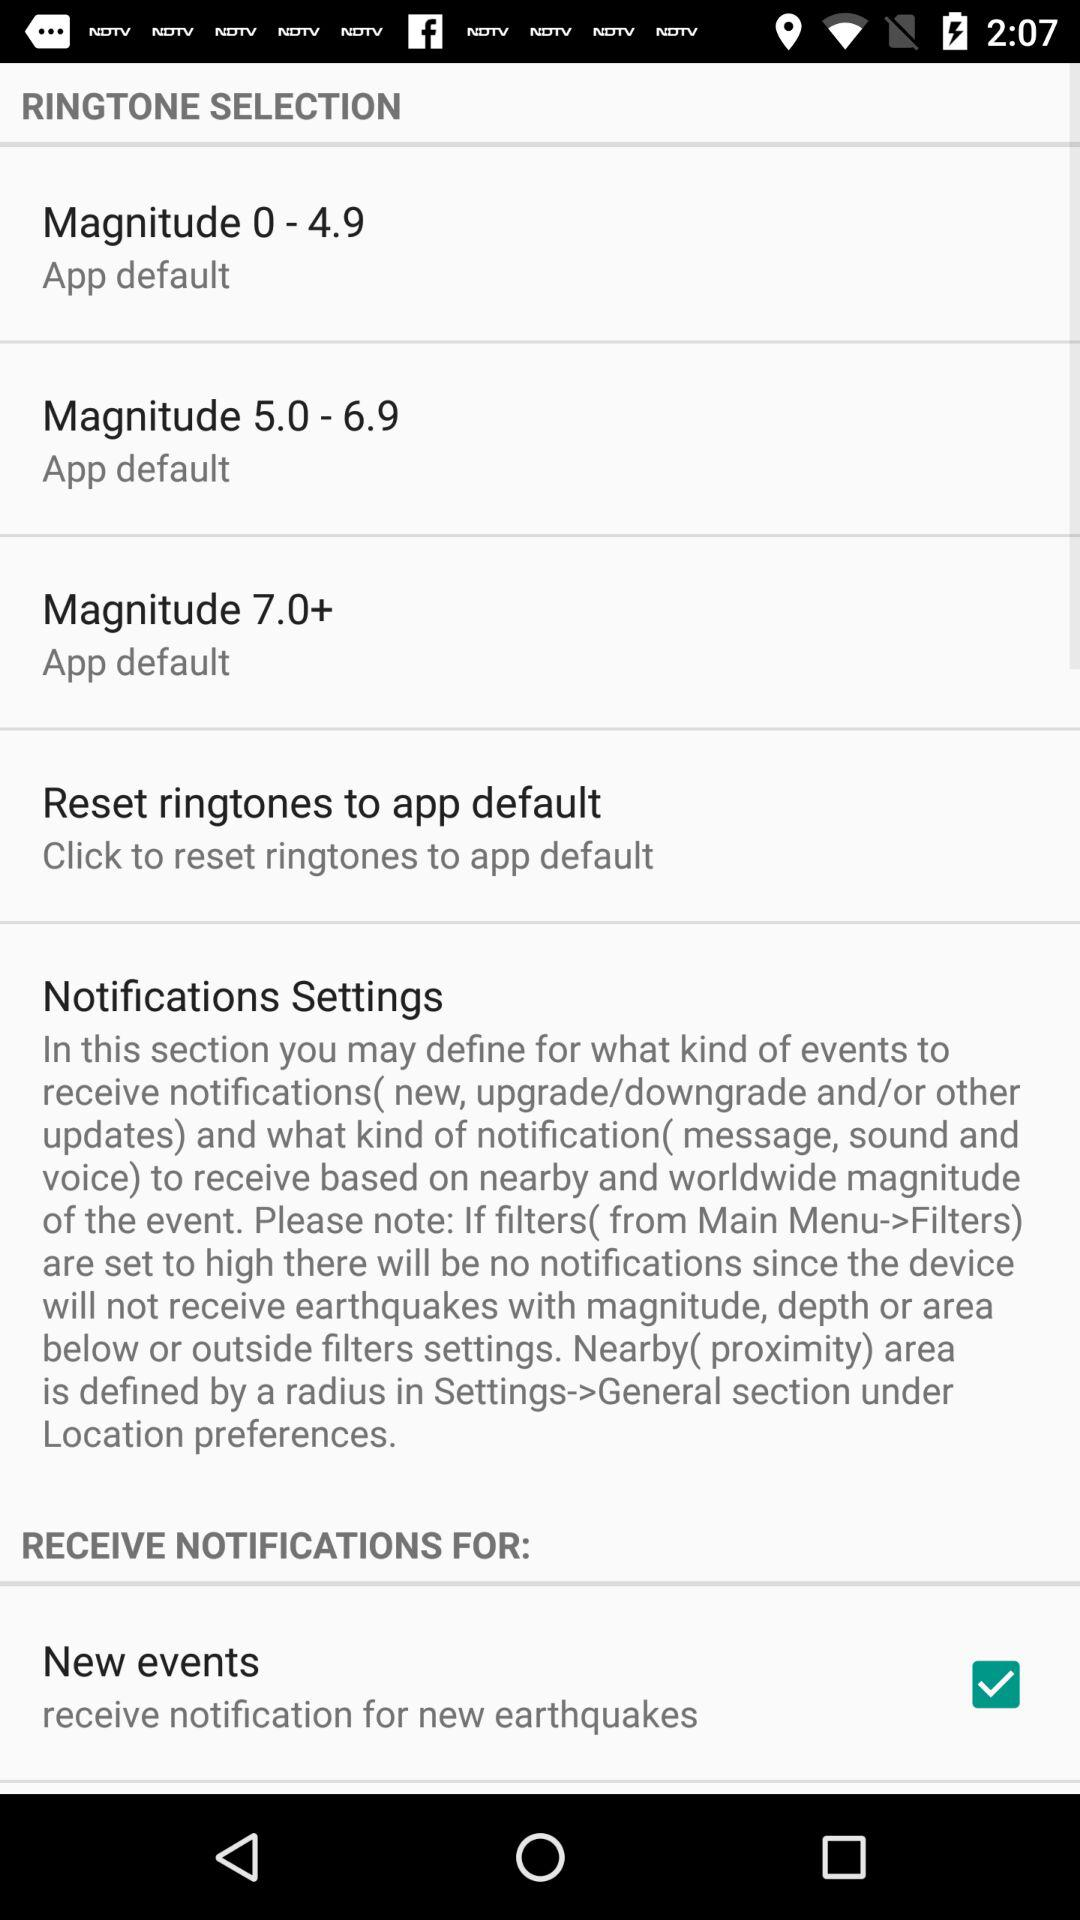What is the status of "New events"? The status is "on". 